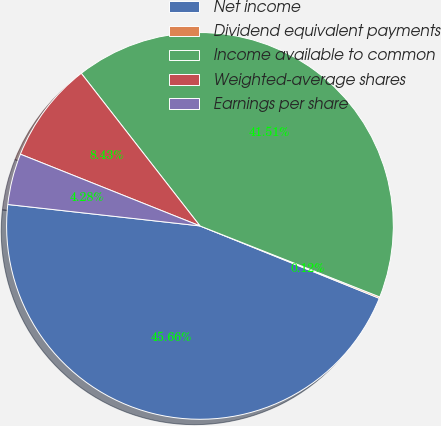Convert chart to OTSL. <chart><loc_0><loc_0><loc_500><loc_500><pie_chart><fcel>Net income<fcel>Dividend equivalent payments<fcel>Income available to common<fcel>Weighted-average shares<fcel>Earnings per share<nl><fcel>45.66%<fcel>0.12%<fcel>41.51%<fcel>8.43%<fcel>4.28%<nl></chart> 